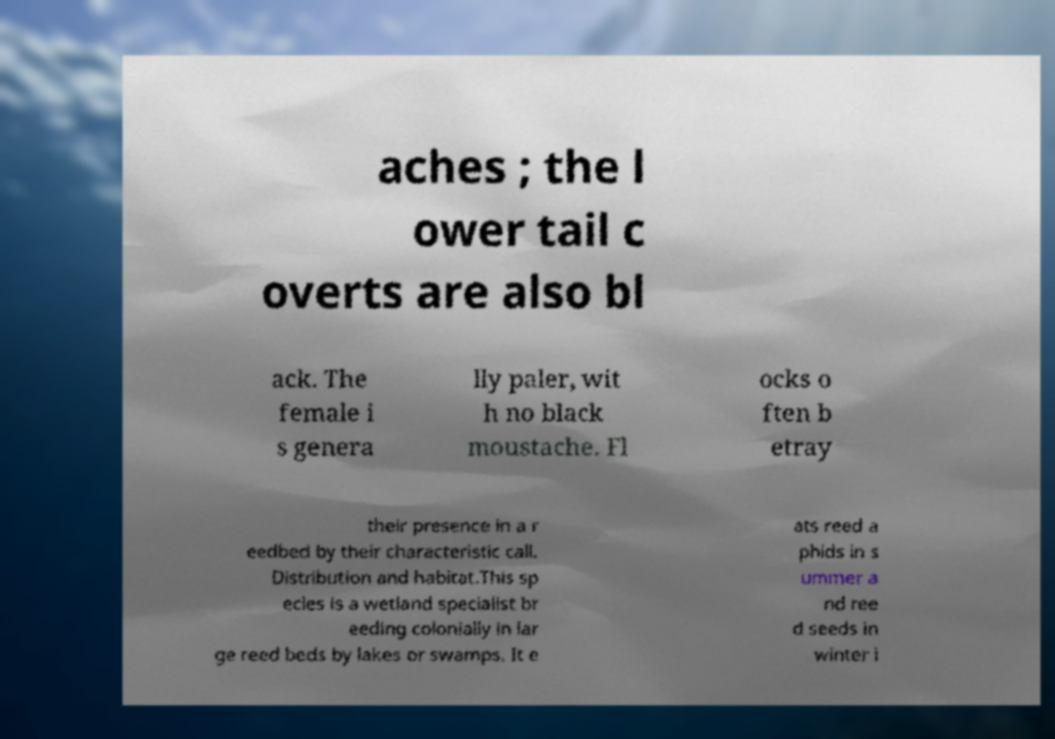Can you accurately transcribe the text from the provided image for me? aches ; the l ower tail c overts are also bl ack. The female i s genera lly paler, wit h no black moustache. Fl ocks o ften b etray their presence in a r eedbed by their characteristic call. Distribution and habitat.This sp ecies is a wetland specialist br eeding colonially in lar ge reed beds by lakes or swamps. It e ats reed a phids in s ummer a nd ree d seeds in winter i 